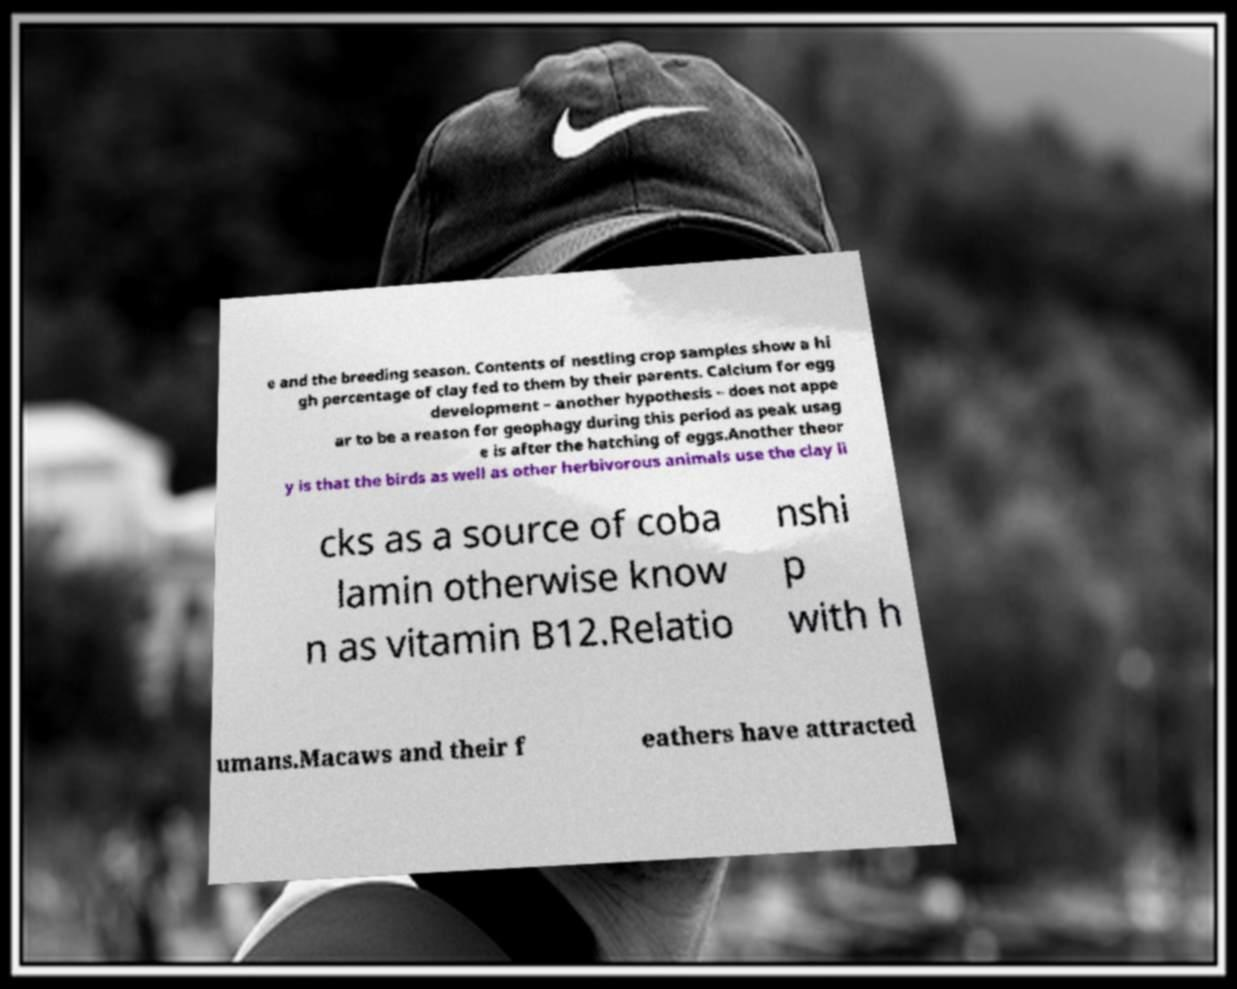There's text embedded in this image that I need extracted. Can you transcribe it verbatim? e and the breeding season. Contents of nestling crop samples show a hi gh percentage of clay fed to them by their parents. Calcium for egg development – another hypothesis – does not appe ar to be a reason for geophagy during this period as peak usag e is after the hatching of eggs.Another theor y is that the birds as well as other herbivorous animals use the clay li cks as a source of coba lamin otherwise know n as vitamin B12.Relatio nshi p with h umans.Macaws and their f eathers have attracted 